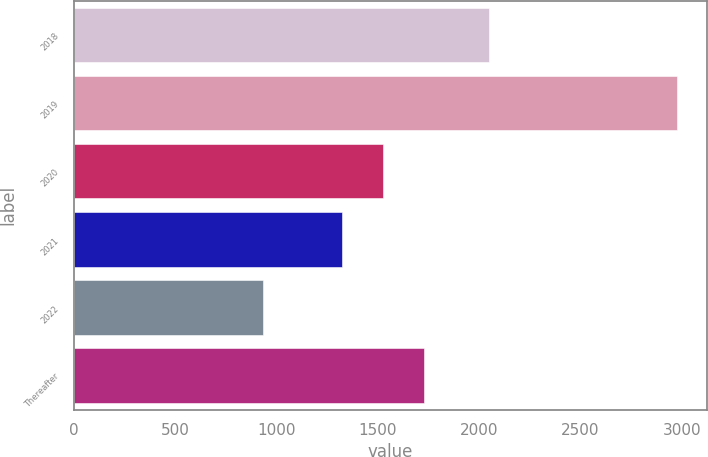Convert chart. <chart><loc_0><loc_0><loc_500><loc_500><bar_chart><fcel>2018<fcel>2019<fcel>2020<fcel>2021<fcel>2022<fcel>Thereafter<nl><fcel>2047<fcel>2975<fcel>1526<fcel>1322<fcel>935<fcel>1730<nl></chart> 